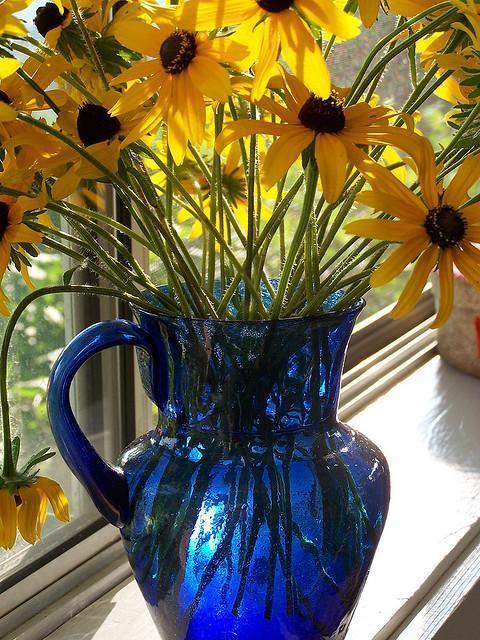How many vases are in the photo?
Give a very brief answer. 2. 